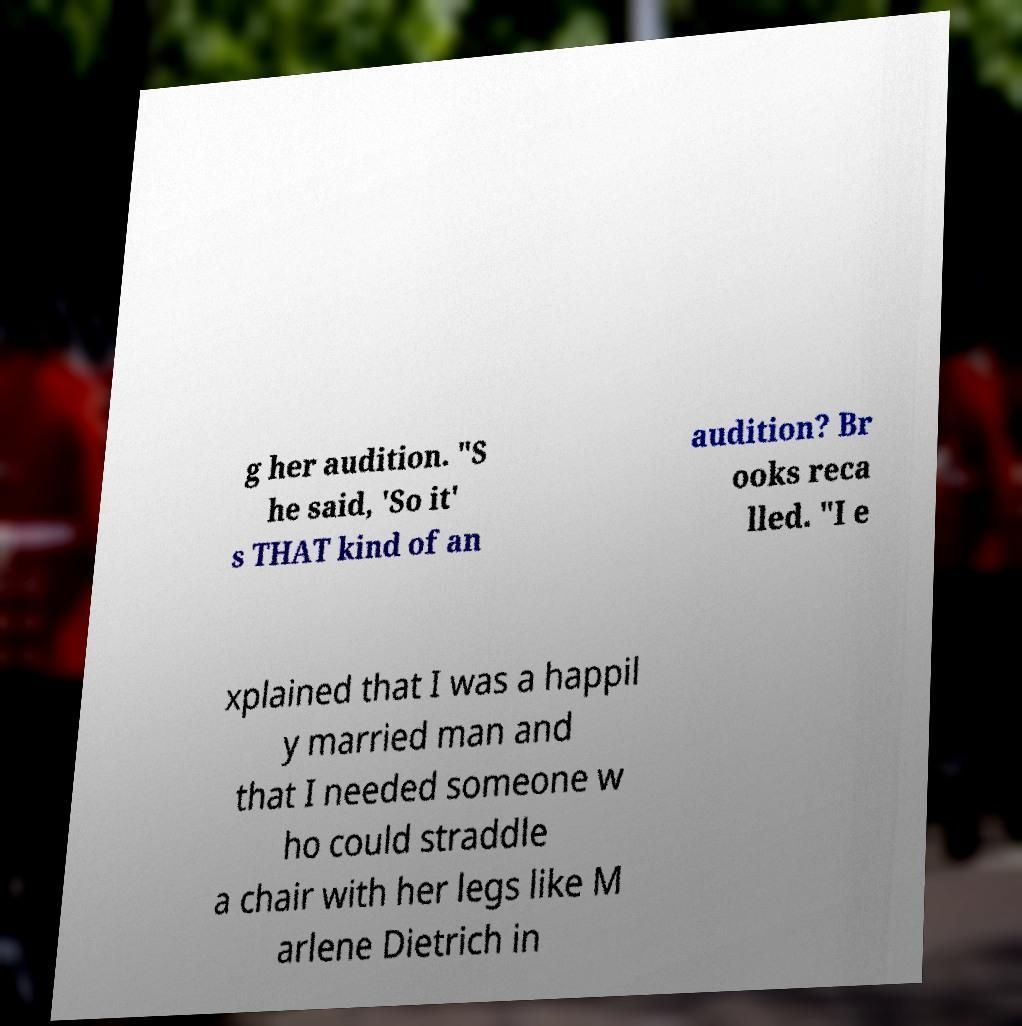Can you accurately transcribe the text from the provided image for me? g her audition. "S he said, 'So it' s THAT kind of an audition? Br ooks reca lled. "I e xplained that I was a happil y married man and that I needed someone w ho could straddle a chair with her legs like M arlene Dietrich in 